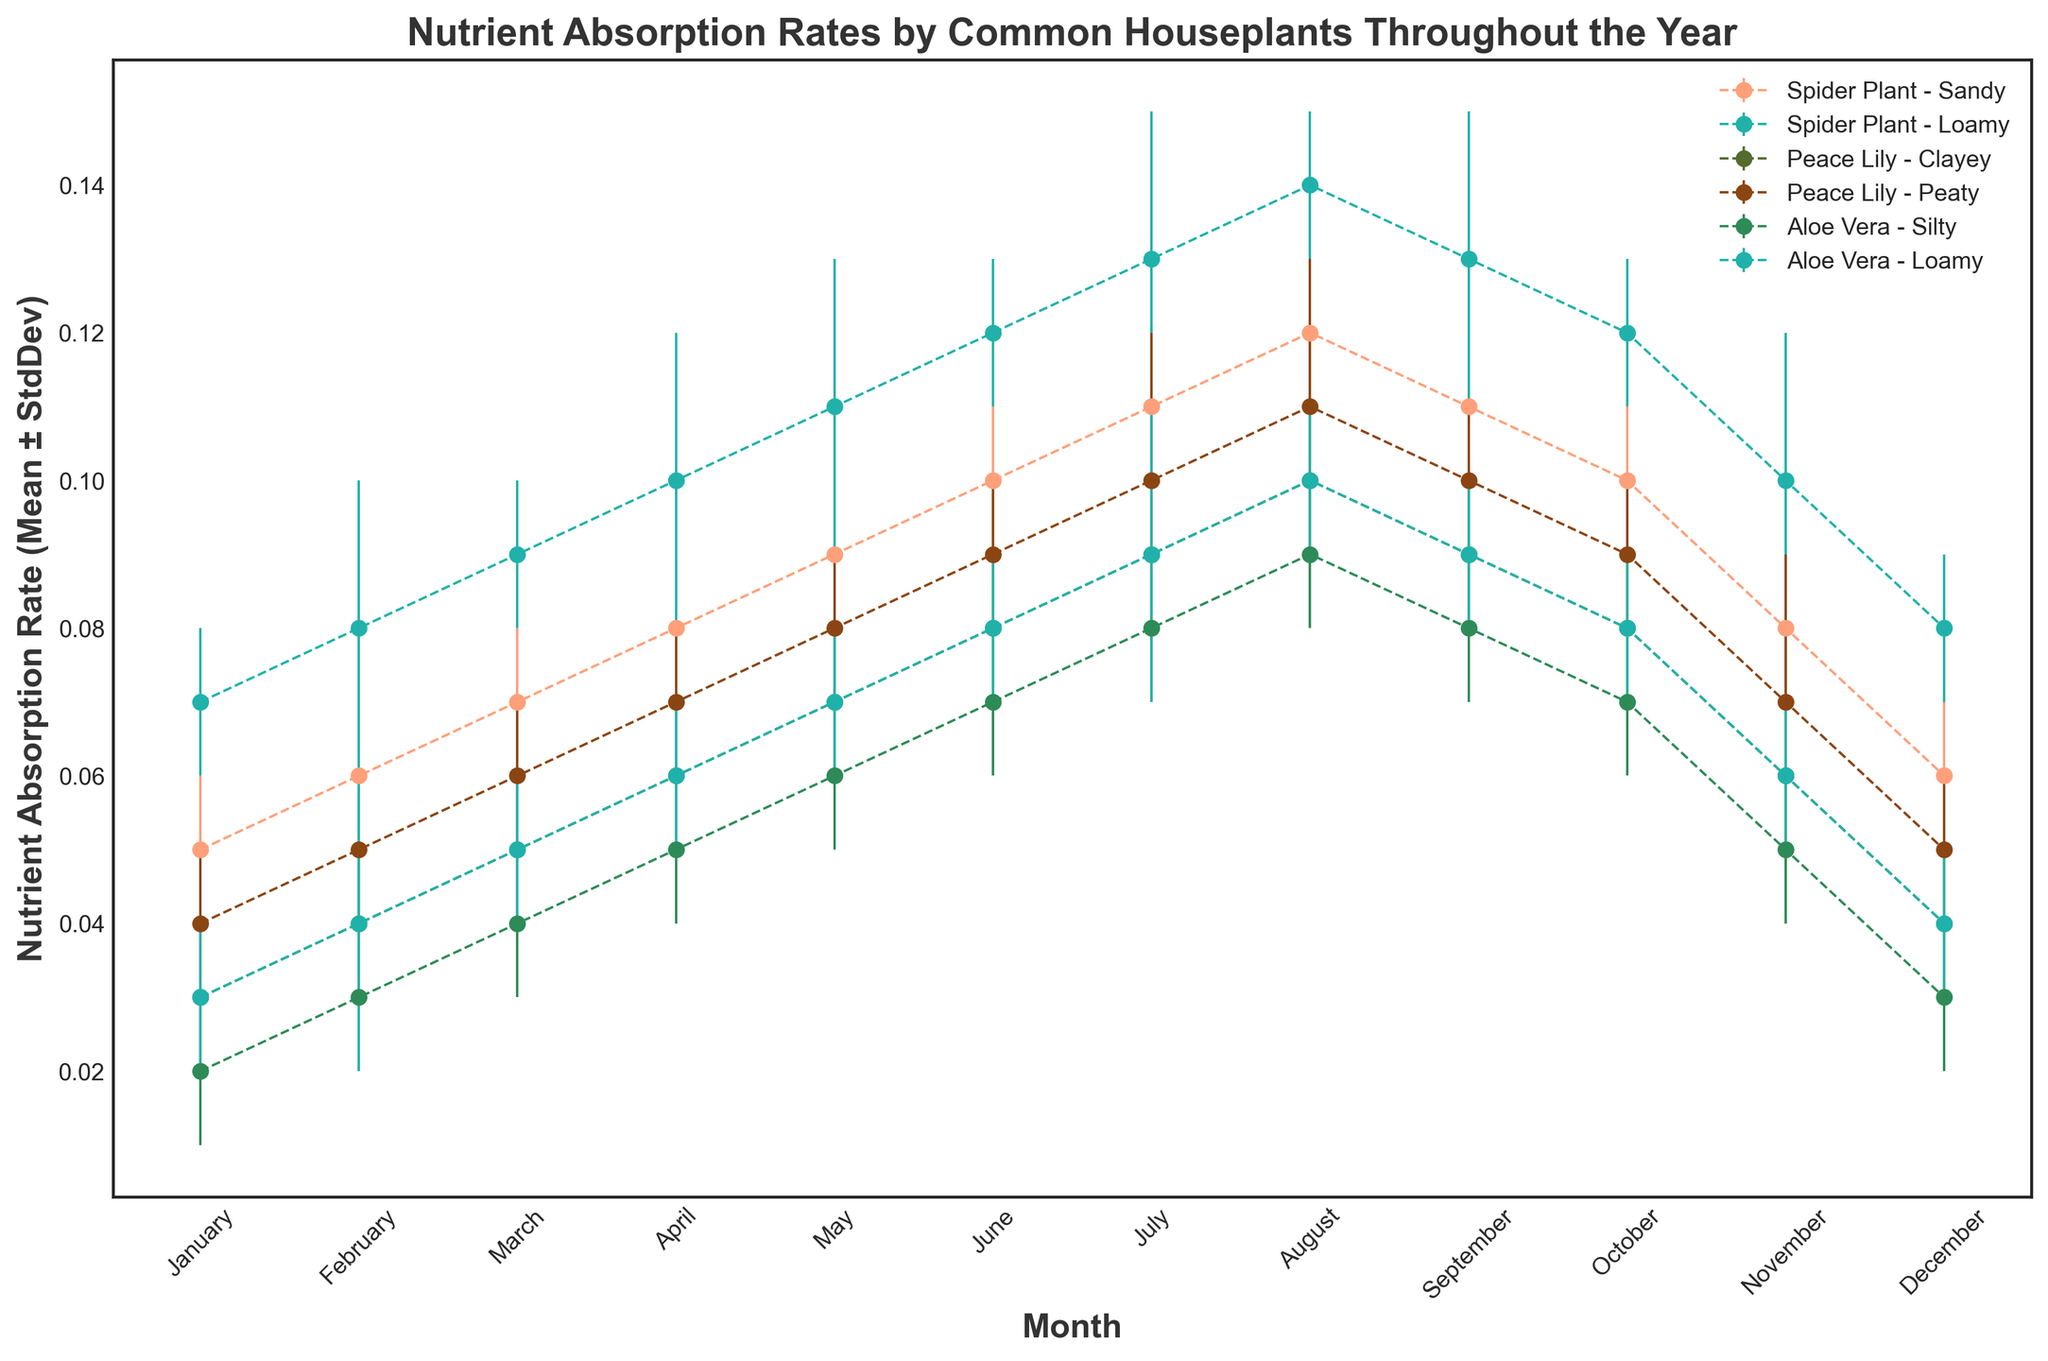What is the average nutrient absorption rate of Spider Plant in Loamy soil during the first quarter of the year? Sum the mean absorption rates for Spider Plant in Loamy soil for January, February, and March (0.07 + 0.08 + 0.09) = 0.24, then divide by 3, the number of months in the first quarter: 0.24 / 3 = 0.08
Answer: 0.08 Which plant-soil combination has the highest nutrient absorption rate in August? The peak nutrient absorption rate in August for the given data is 0.14 for Spider Plant in Loamy soil. Check all plant-soil combinations for their August rates and compare them.
Answer: Spider Plant - Loamy Between July and December, which soil type allows Aloe Vera to absorb nutrients more efficiently on average, Silty or Loamy? Compare mean absorption rates for Aloe Vera in Silty (0.08 + 0.09 + 0.08 + 0.07 + 0.05 + 0.03) = 0.4 and Loamy (0.09 + 0.1 + 0.09 + 0.08 + 0.06 + 0.04) = 0.46; divide each by 6 months to get average rates: Silty: 0.4 / 6 = 0.067, Loamy: 0.46 / 6 = 0.077
Answer: Aloe Vera in Loamy What is the visual trend of nutrient absorption rate for Peace Lily in Clayey soil throughout the year? Observe the error bars for Peace Lily in Clayey soil from January to December. The trend shows a gradual increase from January (0.03) to August (0.1) followed by a decline to December (0.04)
Answer: Increase then decrease Which month shows the minimum nutrient absorption rate for Aloe Vera in Silty soil? Find the lowest point on the nutrient absorption rate line for Aloe Vera in Silty soil. The minimum is in January with a rate of 0.02
Answer: January Are the error margins generally wider for Spider Plant in Sandy soil or for Peace Lily in Peaty soil? Compare the lengths of error bars for Spider Plant in Sandy soil and Peace Lily in Peaty soil across all months. The error margins are generally similar, but Peace Lily in Peaty soil occasionally has wider margins particularly in the last quarter of the year.
Answer: Peace Lily in Peaty 